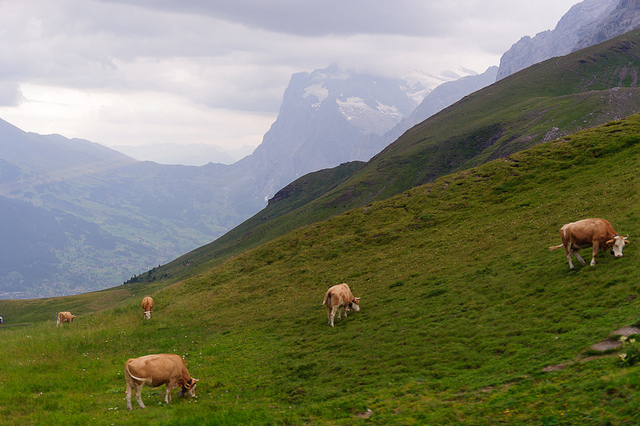<image>What breed of cow is that? I don't know the exact breed of the cow. It could be Holstein, Brown Jersey, Beef Cow, Dairy, Longhorn, Jersey, or Guernsey. What breed of cow is that? I am not sure what breed of cow that is. It could be 'holstein', 'brown jersey', 'beef cow', 'dairy', 'longhorn', 'jersey', or 'guernsey'. 